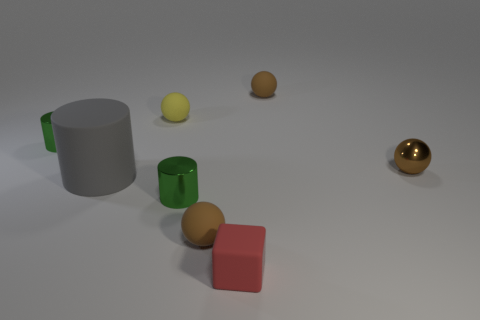What number of big gray matte cylinders are left of the small rubber thing in front of the tiny brown sphere that is in front of the metallic ball?
Keep it short and to the point. 1. Are there any rubber balls of the same color as the tiny metallic sphere?
Provide a short and direct response. Yes. There is a shiny ball that is the same size as the rubber cube; what color is it?
Your answer should be very brief. Brown. Is there another metallic object that has the same shape as the large object?
Keep it short and to the point. Yes. Is there a matte cylinder that is to the right of the thing in front of the brown matte sphere that is on the left side of the tiny red thing?
Offer a terse response. No. The yellow matte object that is the same size as the brown metal ball is what shape?
Provide a short and direct response. Sphere. There is a metallic object that is the same shape as the yellow matte object; what color is it?
Give a very brief answer. Brown. How many things are either small brown balls or small gray cubes?
Keep it short and to the point. 3. There is a metal object in front of the brown metal sphere; is it the same shape as the small brown thing in front of the brown metal sphere?
Your response must be concise. No. There is a green object that is right of the small yellow object; what shape is it?
Make the answer very short. Cylinder. 